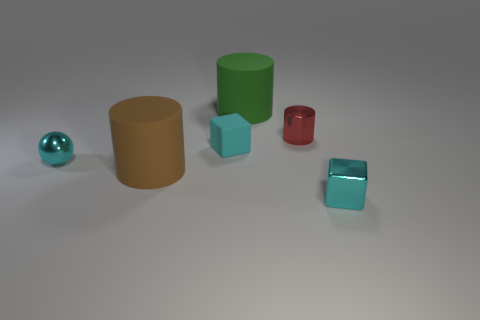Describe the layout of the scene with respect to the cyan sphere. Right next to the cyan sphere, on its right side, there is a large tan cylinder. Further right from there, you'll find a large green matte cylinder, and right-most of all, two cyan blocks—one directly to the right of the green cylinder and another to the right of the first block. The small red cylinder is situated between the two cyan blocks, slightly closer to the foreground. 